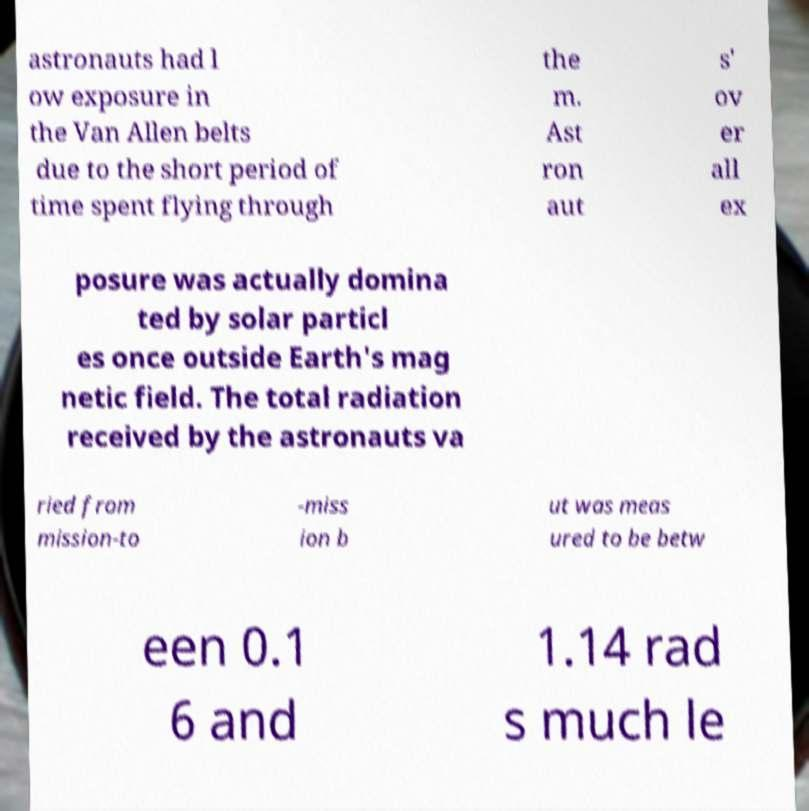I need the written content from this picture converted into text. Can you do that? astronauts had l ow exposure in the Van Allen belts due to the short period of time spent flying through the m. Ast ron aut s' ov er all ex posure was actually domina ted by solar particl es once outside Earth's mag netic field. The total radiation received by the astronauts va ried from mission-to -miss ion b ut was meas ured to be betw een 0.1 6 and 1.14 rad s much le 